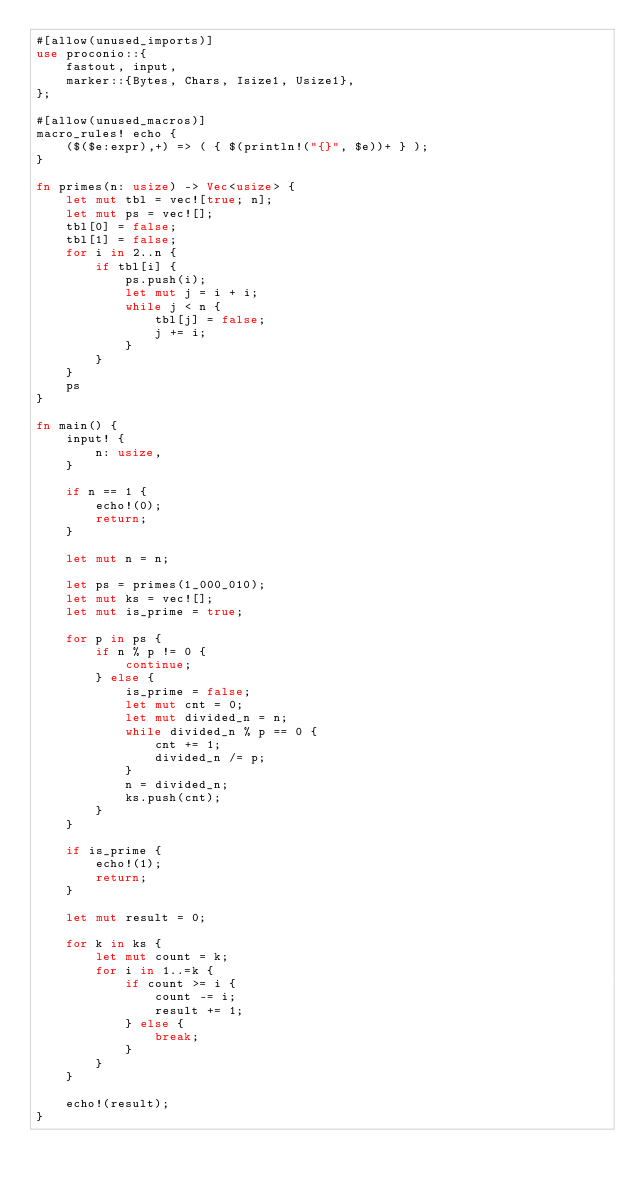<code> <loc_0><loc_0><loc_500><loc_500><_Rust_>#[allow(unused_imports)]
use proconio::{
    fastout, input,
    marker::{Bytes, Chars, Isize1, Usize1},
};

#[allow(unused_macros)]
macro_rules! echo {
    ($($e:expr),+) => ( { $(println!("{}", $e))+ } );
}

fn primes(n: usize) -> Vec<usize> {
    let mut tbl = vec![true; n];
    let mut ps = vec![];
    tbl[0] = false;
    tbl[1] = false;
    for i in 2..n {
        if tbl[i] {
            ps.push(i);
            let mut j = i + i;
            while j < n {
                tbl[j] = false;
                j += i;
            }
        }
    }
    ps
}

fn main() {
    input! {
        n: usize,
    }

    if n == 1 {
        echo!(0);
        return;
    }

    let mut n = n;

    let ps = primes(1_000_010);
    let mut ks = vec![];
    let mut is_prime = true;

    for p in ps {
        if n % p != 0 {
            continue;
        } else {
            is_prime = false;
            let mut cnt = 0;
            let mut divided_n = n;
            while divided_n % p == 0 {
                cnt += 1;
                divided_n /= p;
            }
            n = divided_n;
            ks.push(cnt);
        }
    }

    if is_prime {
        echo!(1);
        return;
    }

    let mut result = 0;

    for k in ks {
        let mut count = k;
        for i in 1..=k {
            if count >= i {
                count -= i;
                result += 1;
            } else {
                break;
            }
        }
    }

    echo!(result);
}
</code> 